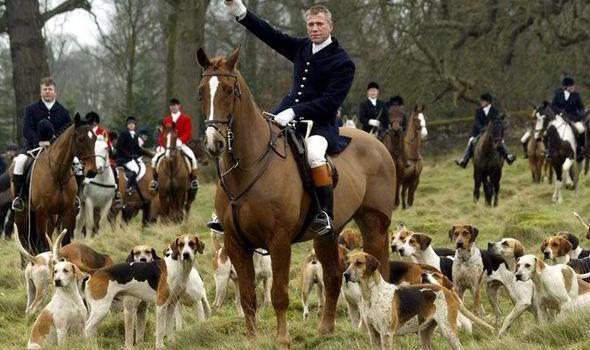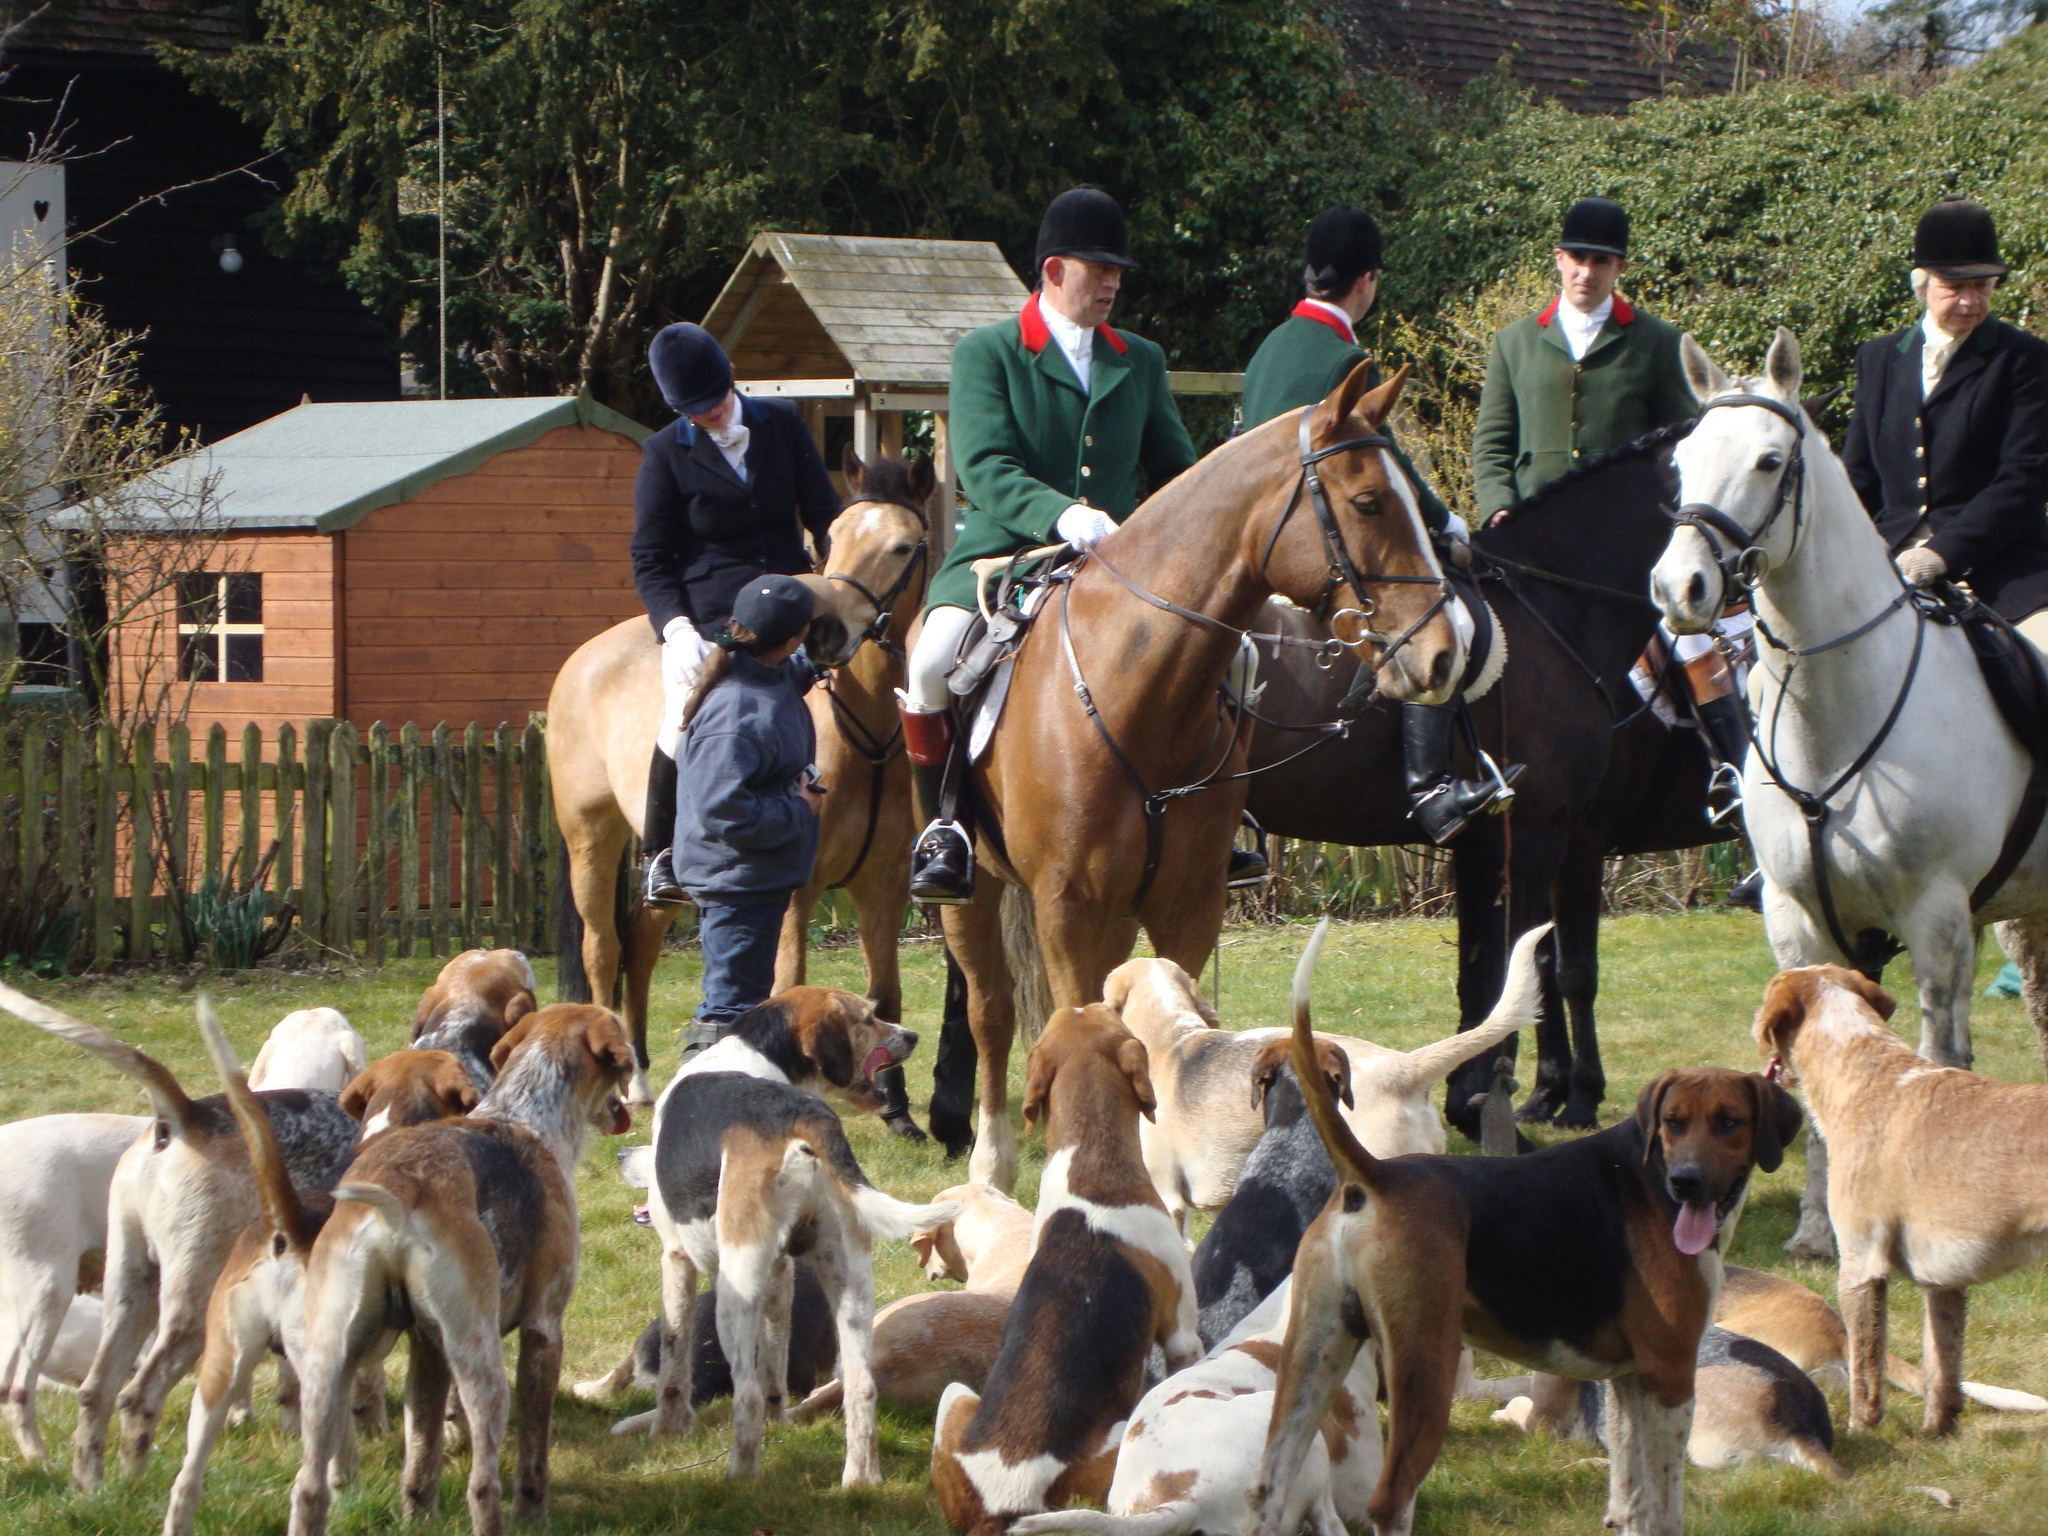The first image is the image on the left, the second image is the image on the right. Given the left and right images, does the statement "A man in green jacket, equestrian cap and white pants is astride a horse in the foreground of one image." hold true? Answer yes or no. Yes. The first image is the image on the left, the second image is the image on the right. Assess this claim about the two images: "At least four riders are on horses near the dogs.". Correct or not? Answer yes or no. Yes. 